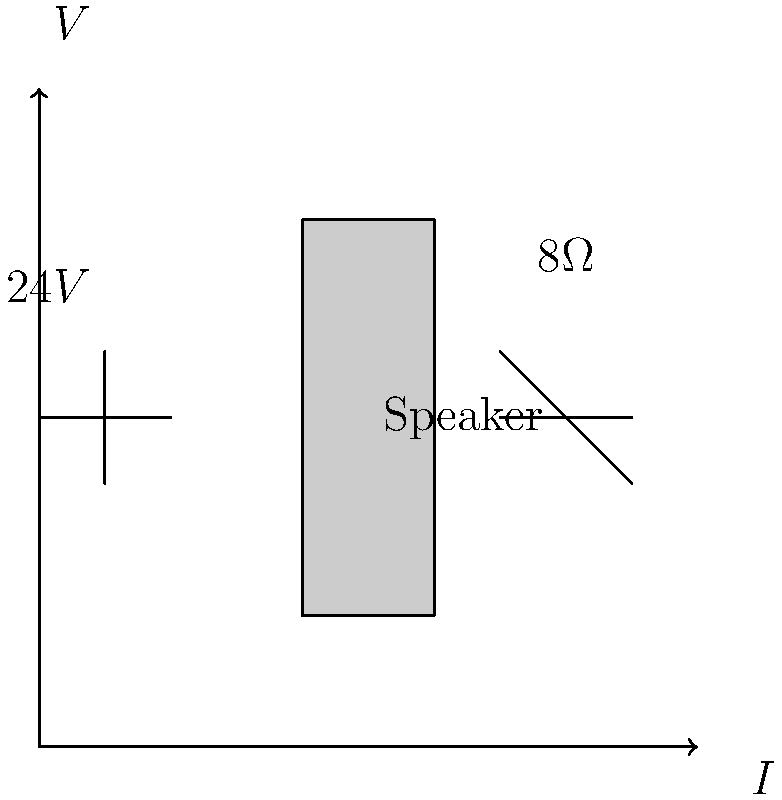At a recent Bruce Springsteen concert, the sound engineers used a speaker system represented by the circuit diagram above. If the voltage source provides 24V and the speaker has an impedance of 8Ω, what is the power output of the speaker system? Assume ideal conditions and that all power is delivered to the speaker. To determine the power output of the speaker system, we'll follow these steps:

1. Identify the given values:
   - Voltage (V) = 24V
   - Speaker impedance (R) = 8Ω

2. Calculate the current (I) using Ohm's Law:
   $I = \frac{V}{R} = \frac{24V}{8\Omega} = 3A$

3. Calculate the power (P) using the power formula:
   $P = VI = 24V \times 3A = 72W$

   Alternatively, we could use:
   $P = I^2R = (3A)^2 \times 8\Omega = 72W$
   or
   $P = \frac{V^2}{R} = \frac{(24V)^2}{8\Omega} = 72W$

Therefore, under ideal conditions, the power output of the speaker system used in Bruce Springsteen's concert is 72 watts.
Answer: 72W 